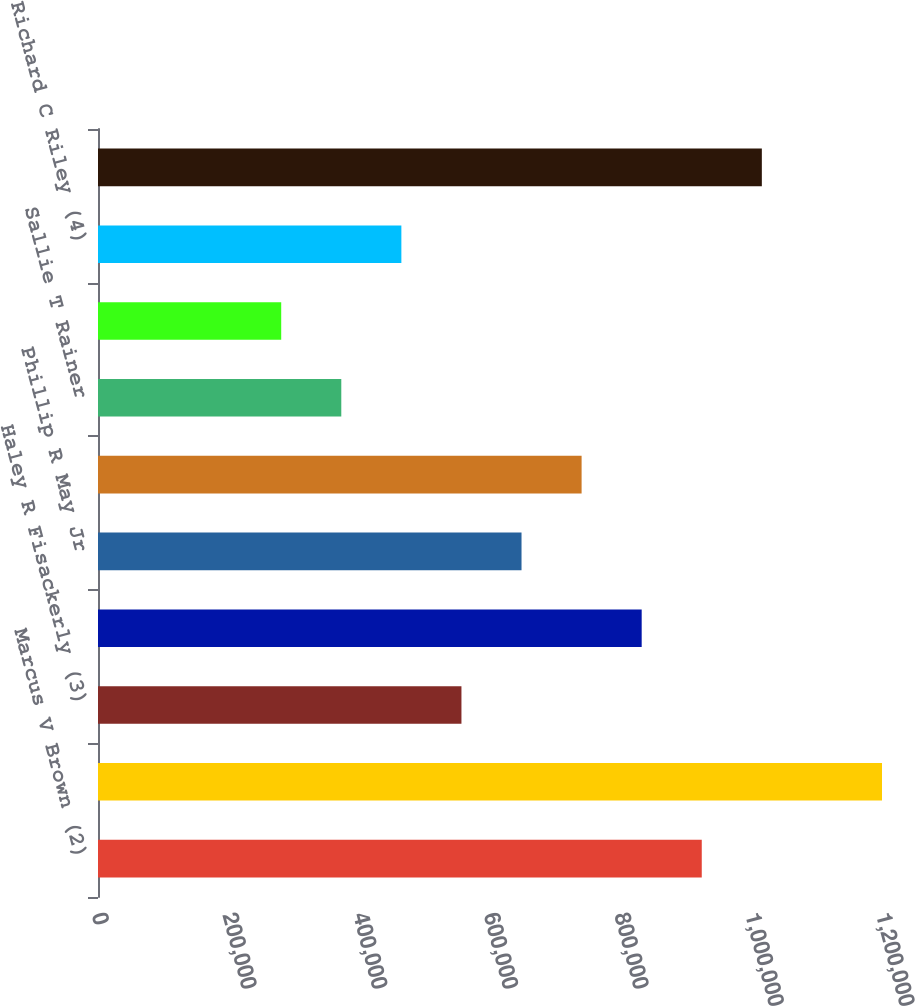<chart> <loc_0><loc_0><loc_500><loc_500><bar_chart><fcel>Marcus V Brown (2)<fcel>Leo P Denault<fcel>Haley R Fisackerly (3)<fcel>Andrew S Marsh<fcel>Phillip R May Jr<fcel>Hugh T McDonald<fcel>Sallie T Rainer<fcel>Charles L Rice Jr<fcel>Richard C Riley (4)<fcel>Roderick K West<nl><fcel>924127<fcel>1.2e+06<fcel>556297<fcel>832170<fcel>648254<fcel>740212<fcel>372382<fcel>280424<fcel>464339<fcel>1.01608e+06<nl></chart> 